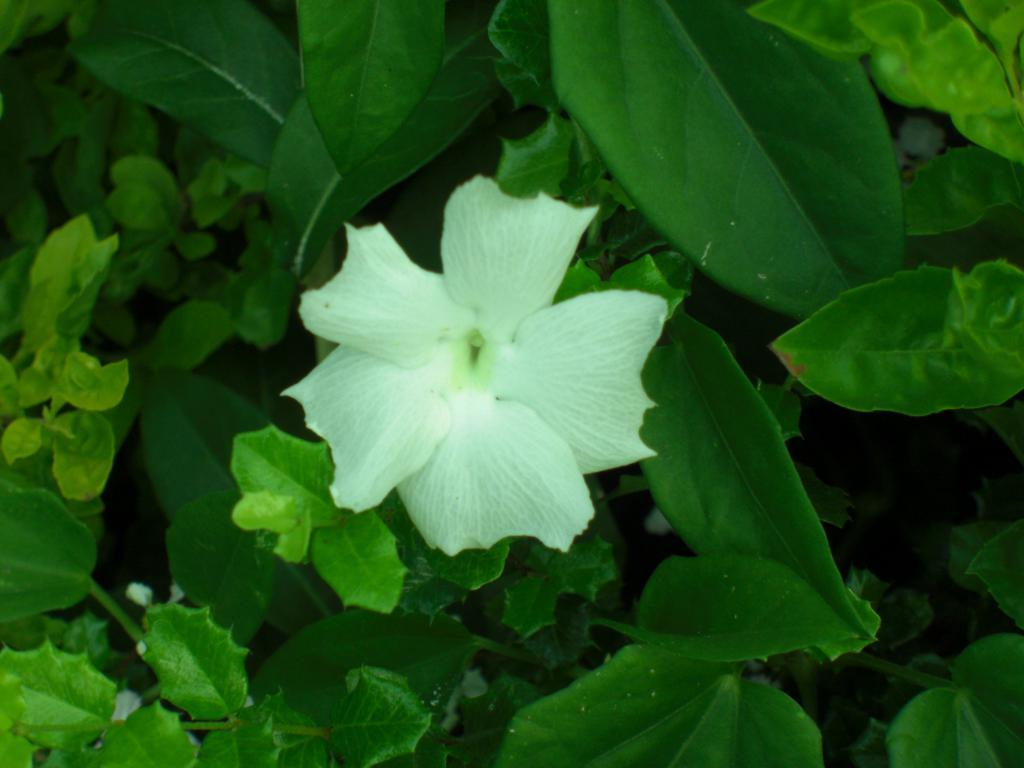What type of flower is in the image? There is a white color flower in the image. What else can be seen in the image besides the flower? There are leaves in the image. What type of cheese is being eaten by the bears in the image? There are no bears or cheese present in the image; it only features a white color flower and leaves. 